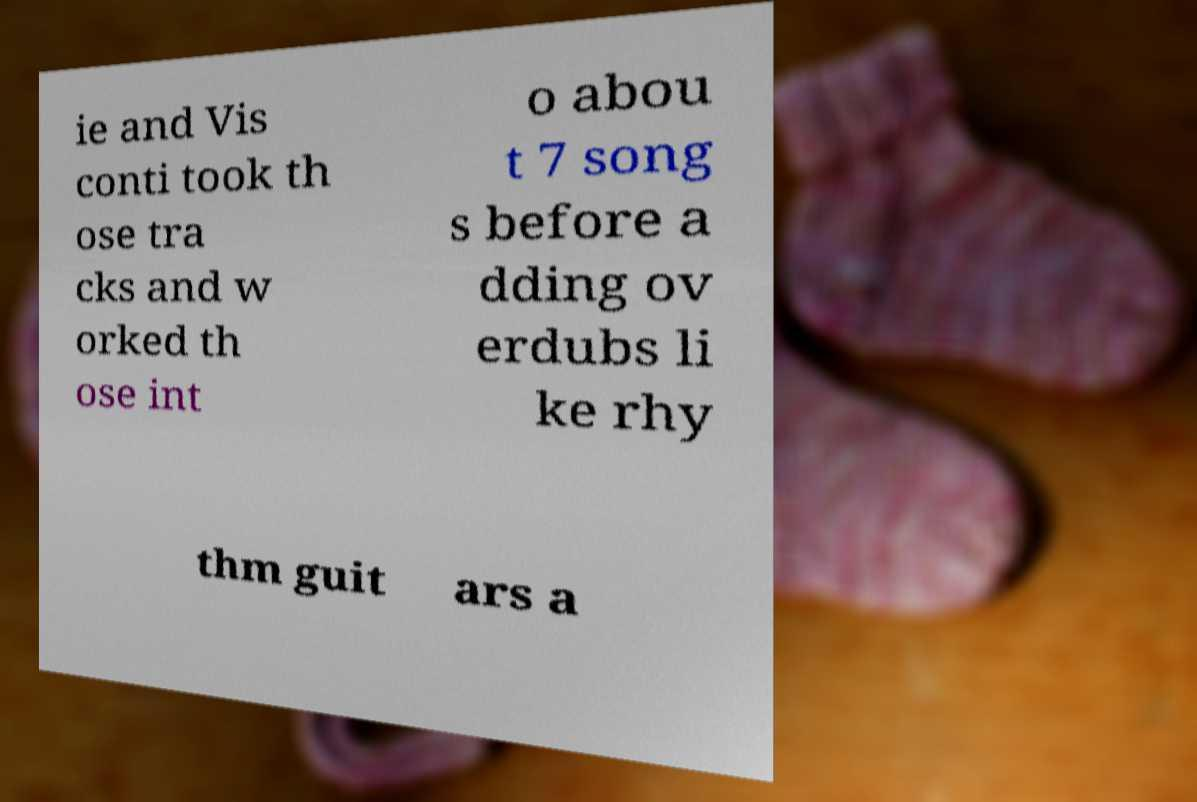Please read and relay the text visible in this image. What does it say? ie and Vis conti took th ose tra cks and w orked th ose int o abou t 7 song s before a dding ov erdubs li ke rhy thm guit ars a 